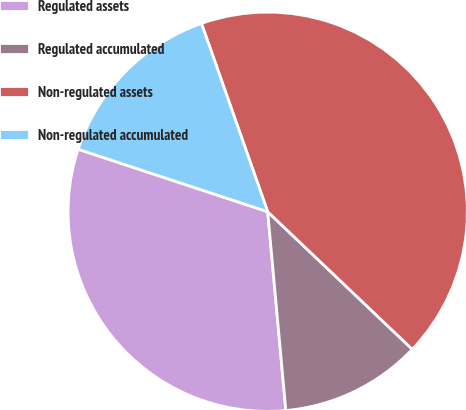Convert chart to OTSL. <chart><loc_0><loc_0><loc_500><loc_500><pie_chart><fcel>Regulated assets<fcel>Regulated accumulated<fcel>Non-regulated assets<fcel>Non-regulated accumulated<nl><fcel>31.52%<fcel>11.45%<fcel>42.49%<fcel>14.55%<nl></chart> 